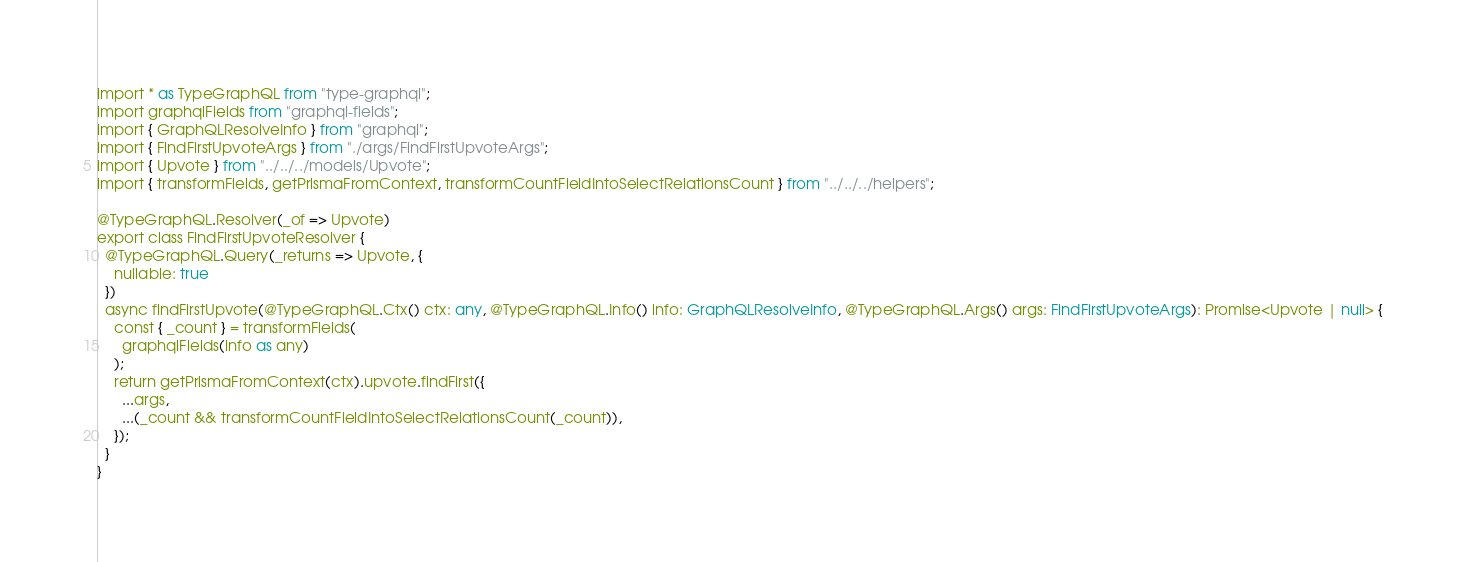Convert code to text. <code><loc_0><loc_0><loc_500><loc_500><_TypeScript_>import * as TypeGraphQL from "type-graphql";
import graphqlFields from "graphql-fields";
import { GraphQLResolveInfo } from "graphql";
import { FindFirstUpvoteArgs } from "./args/FindFirstUpvoteArgs";
import { Upvote } from "../../../models/Upvote";
import { transformFields, getPrismaFromContext, transformCountFieldIntoSelectRelationsCount } from "../../../helpers";

@TypeGraphQL.Resolver(_of => Upvote)
export class FindFirstUpvoteResolver {
  @TypeGraphQL.Query(_returns => Upvote, {
    nullable: true
  })
  async findFirstUpvote(@TypeGraphQL.Ctx() ctx: any, @TypeGraphQL.Info() info: GraphQLResolveInfo, @TypeGraphQL.Args() args: FindFirstUpvoteArgs): Promise<Upvote | null> {
    const { _count } = transformFields(
      graphqlFields(info as any)
    );
    return getPrismaFromContext(ctx).upvote.findFirst({
      ...args,
      ...(_count && transformCountFieldIntoSelectRelationsCount(_count)),
    });
  }
}
</code> 